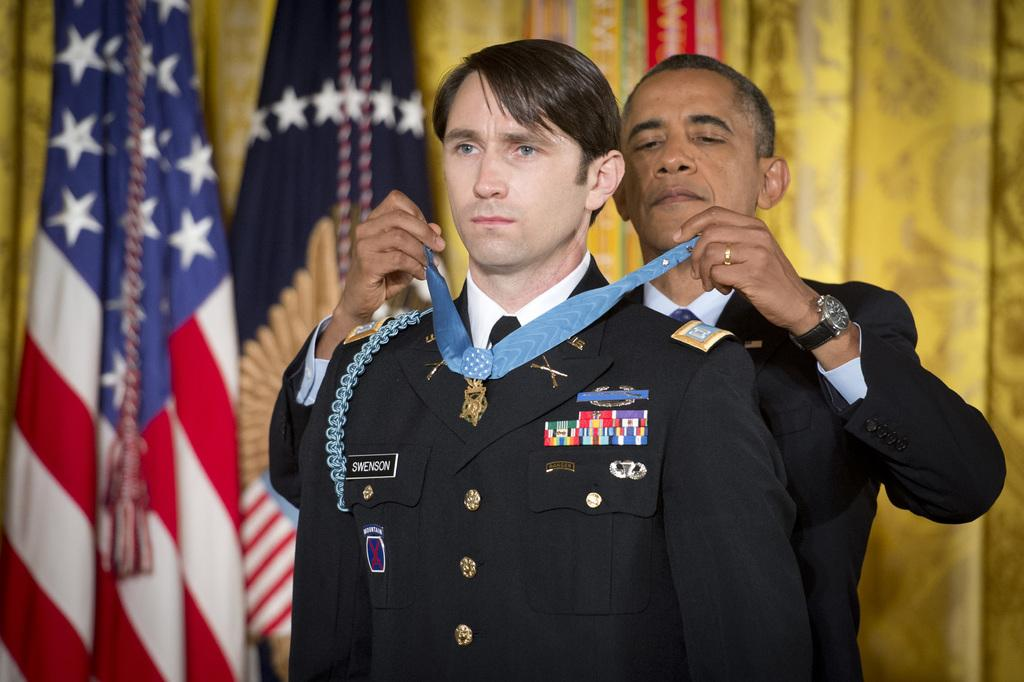<image>
Give a short and clear explanation of the subsequent image. President Obama is pinning a medal on a man's military uniform which says Swenson. 